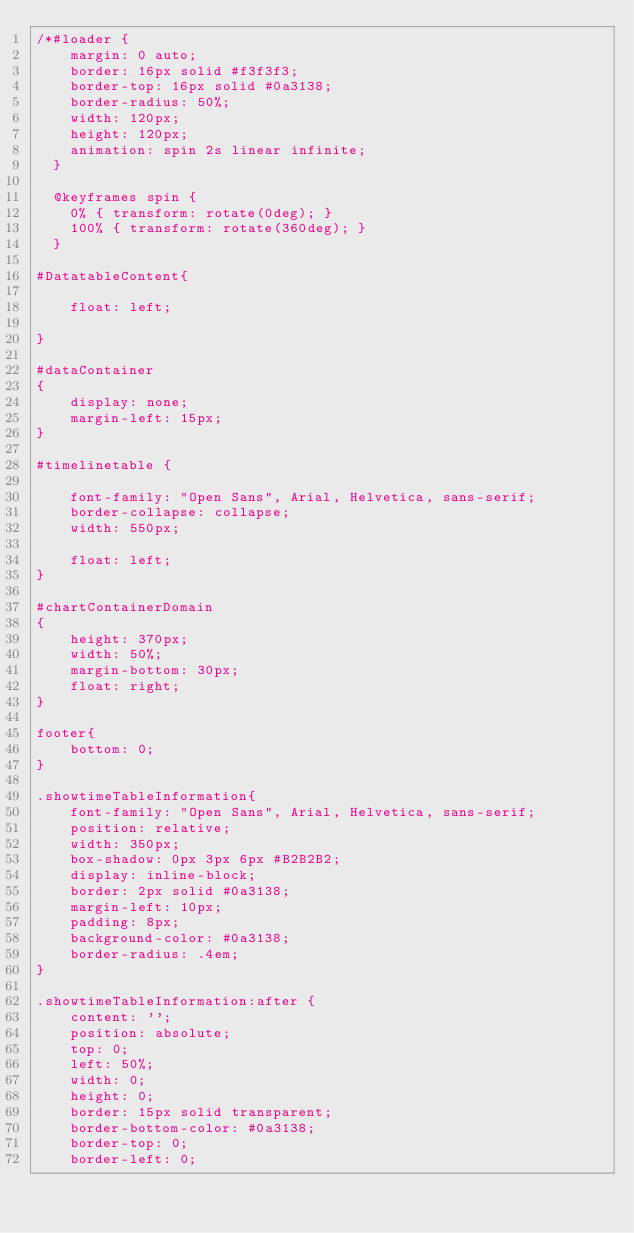<code> <loc_0><loc_0><loc_500><loc_500><_CSS_>/*#loader {
    margin: 0 auto;
    border: 16px solid #f3f3f3;
    border-top: 16px solid #0a3138;
    border-radius: 50%;
    width: 120px;
    height: 120px;
    animation: spin 2s linear infinite;
  }

  @keyframes spin {
    0% { transform: rotate(0deg); }
    100% { transform: rotate(360deg); }
  }

#DatatableContent{

    float: left;

}

#dataContainer
{
    display: none;
    margin-left: 15px;
}

#timelinetable {

    font-family: "Open Sans", Arial, Helvetica, sans-serif;
    border-collapse: collapse;
    width: 550px;

    float: left;
}

#chartContainerDomain
{
    height: 370px;
    width: 50%;
    margin-bottom: 30px;
    float: right;
}

footer{
    bottom: 0;
}

.showtimeTableInformation{
    font-family: "Open Sans", Arial, Helvetica, sans-serif;
    position: relative;
    width: 350px;
    box-shadow: 0px 3px 6px #B2B2B2;
    display: inline-block;
    border: 2px solid #0a3138;
    margin-left: 10px;
    padding: 8px;
    background-color: #0a3138;
    border-radius: .4em;
}

.showtimeTableInformation:after {
    content: '';
    position: absolute;
    top: 0;
    left: 50%;
    width: 0;
    height: 0;
    border: 15px solid transparent;
    border-bottom-color: #0a3138;
    border-top: 0;
    border-left: 0;</code> 